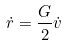Convert formula to latex. <formula><loc_0><loc_0><loc_500><loc_500>\dot { r } = \frac { G } { 2 } \dot { v }</formula> 